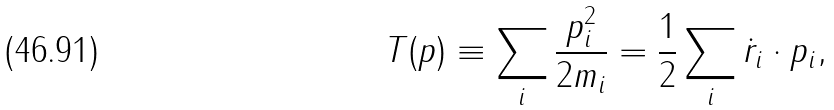Convert formula to latex. <formula><loc_0><loc_0><loc_500><loc_500>T ( p ) \equiv \sum _ { i } \frac { p _ { i } ^ { 2 } } { 2 m _ { i } } = \frac { 1 } { 2 } \sum _ { i } \dot { r } _ { i } \cdot p _ { i } ,</formula> 